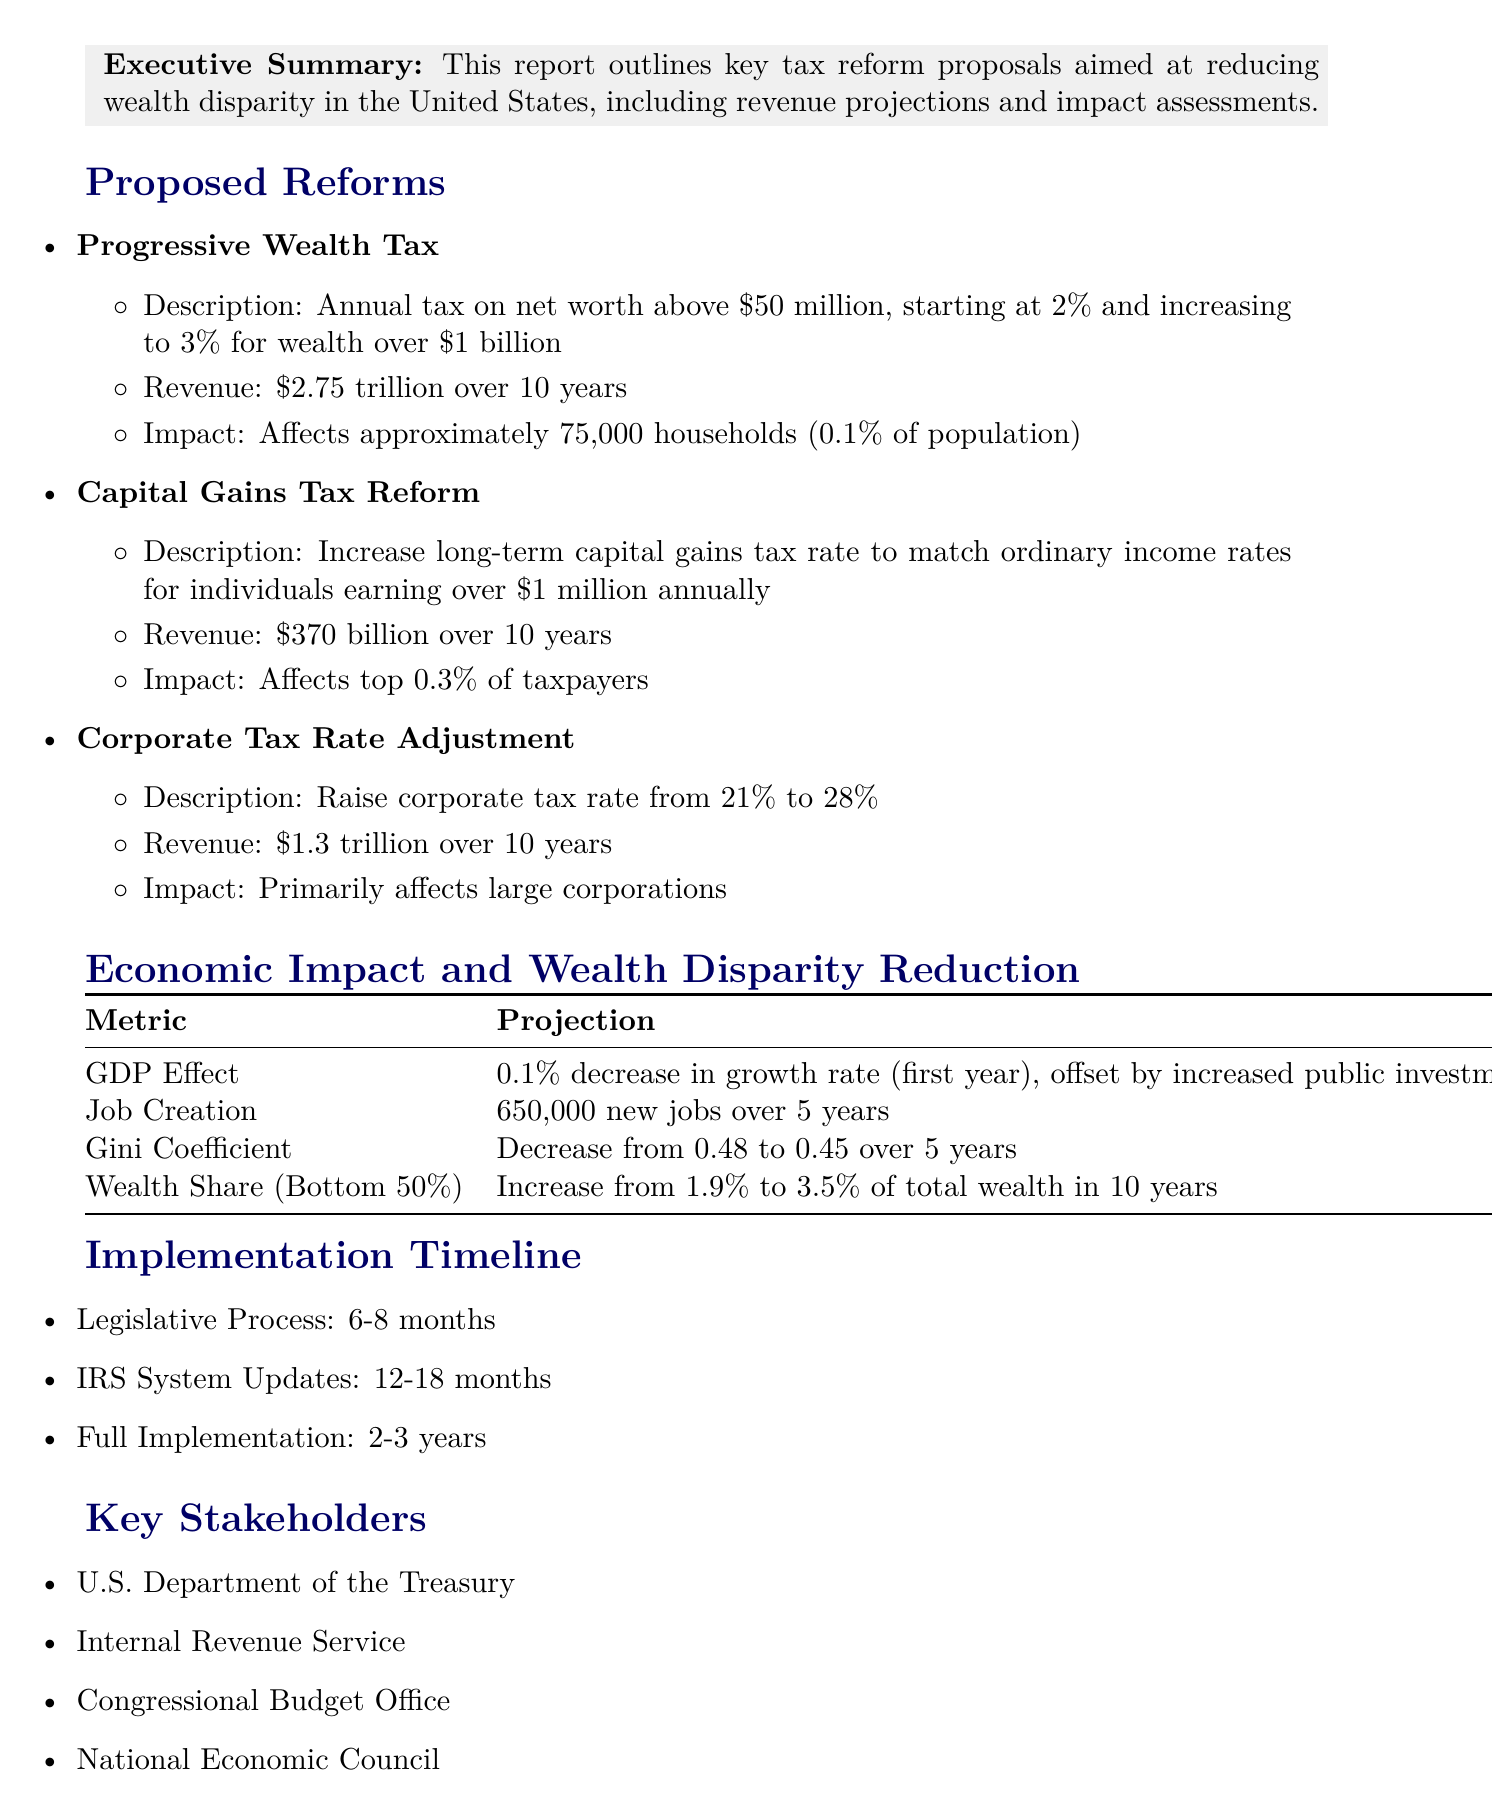What is the title of the report? The title of the report is stated at the beginning of the document.
Answer: Proposed Tax Reforms for Equitable Wealth Distribution How many households will be affected by the Progressive Wealth Tax? The document specifies that approximately 75,000 households will be affected.
Answer: 75,000 households What is the proposed increase in the corporate tax rate? The document indicates that the corporate tax rate will be raised from 21% to 28%.
Answer: 28% What is the projected revenue from Capital Gains Tax Reform over 10 years? The revenue from Capital Gains Tax Reform is detailed in the proposed reforms section.
Answer: $370 billion What is the estimated job creation over 5 years due to the proposed reforms? The document provides an estimate for new jobs created as a result of increased government spending.
Answer: 650,000 new jobs What is the projected Gini coefficient after the implementation of the reforms? The report projects a decrease in the Gini coefficient from 0.48 to 0.45 over 5 years.
Answer: 0.45 How long is the legislative process expected to take? The timeline for the legislative process is explicitly stated in the implementation timeline section.
Answer: 6-8 months Which department is listed as a key stakeholder in the proposed tax reforms? Key stakeholders are listed in a specific section of the document, one of which is the U.S. Department of the Treasury.
Answer: U.S. Department of the Treasury 